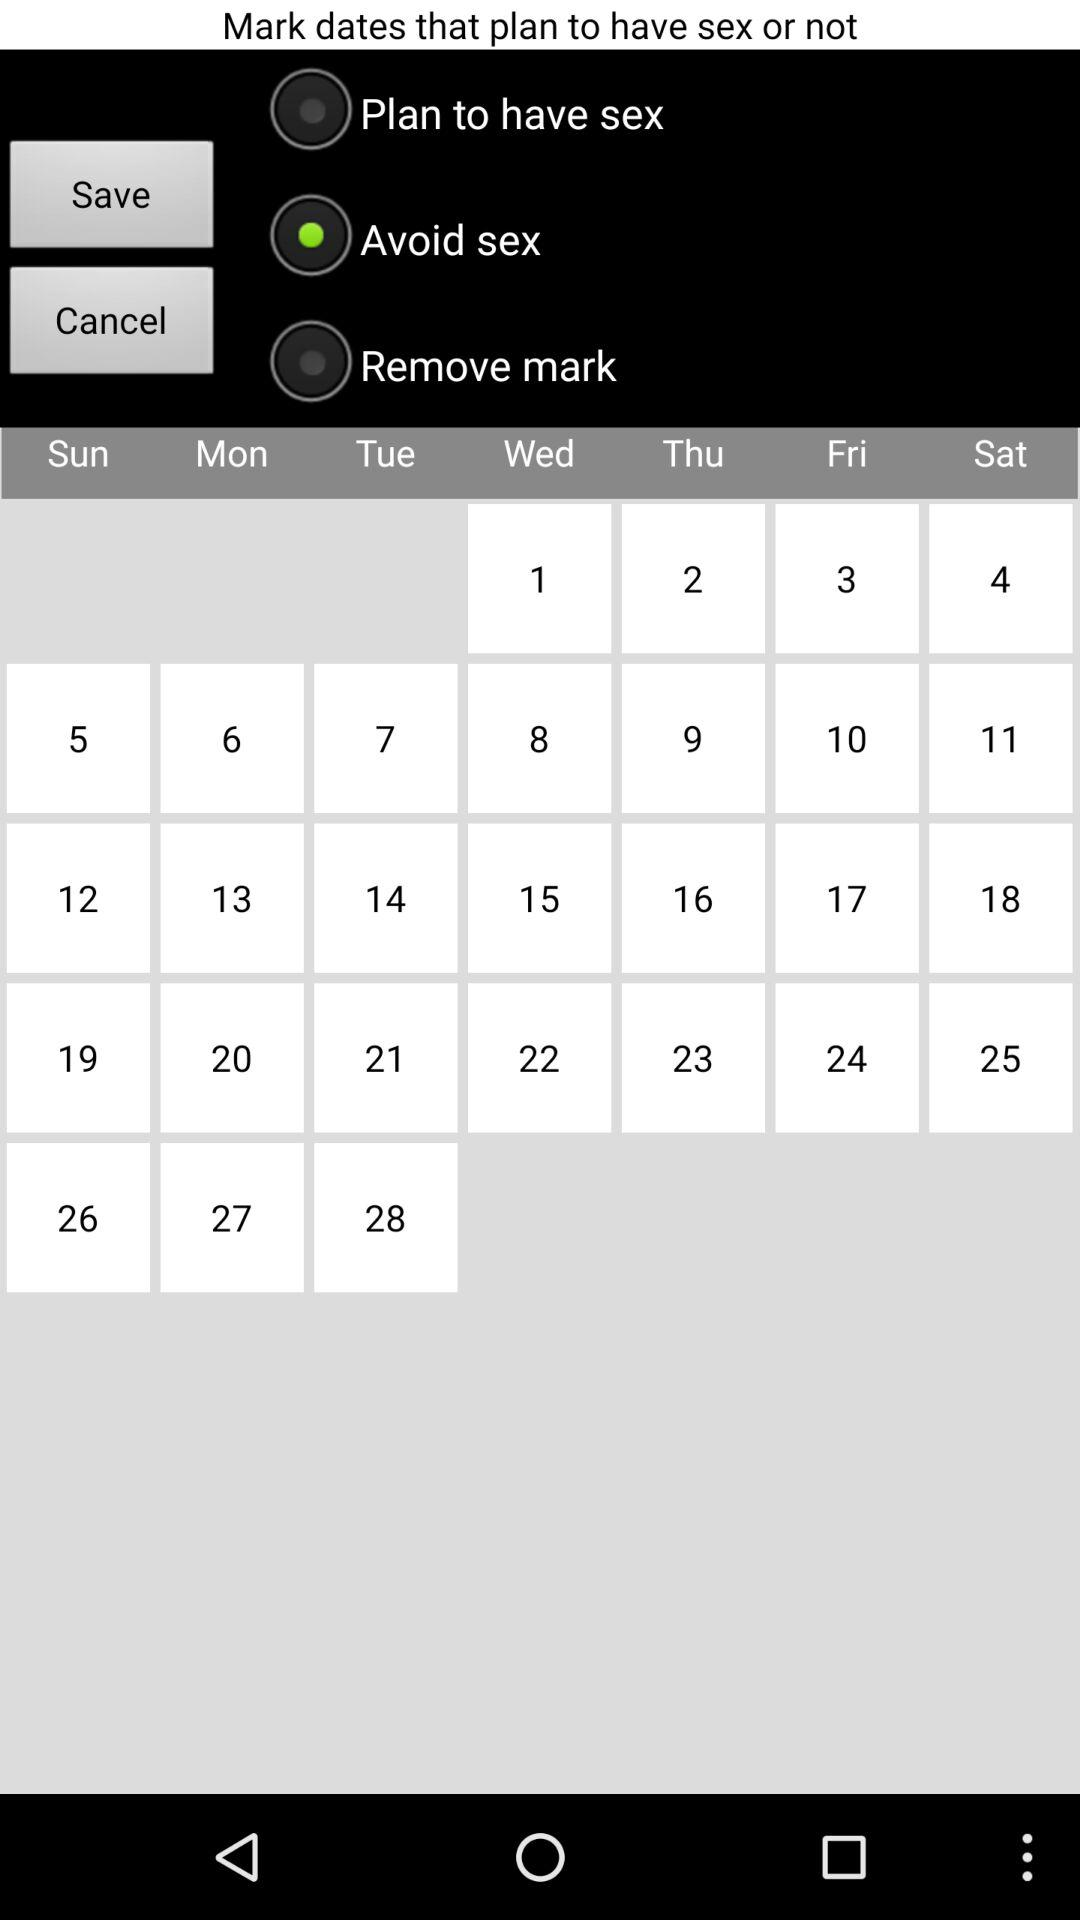Which option has been selected? The option that has been selected is "Avoid sex". 